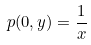Convert formula to latex. <formula><loc_0><loc_0><loc_500><loc_500>p ( 0 , y ) = \frac { 1 } { x }</formula> 